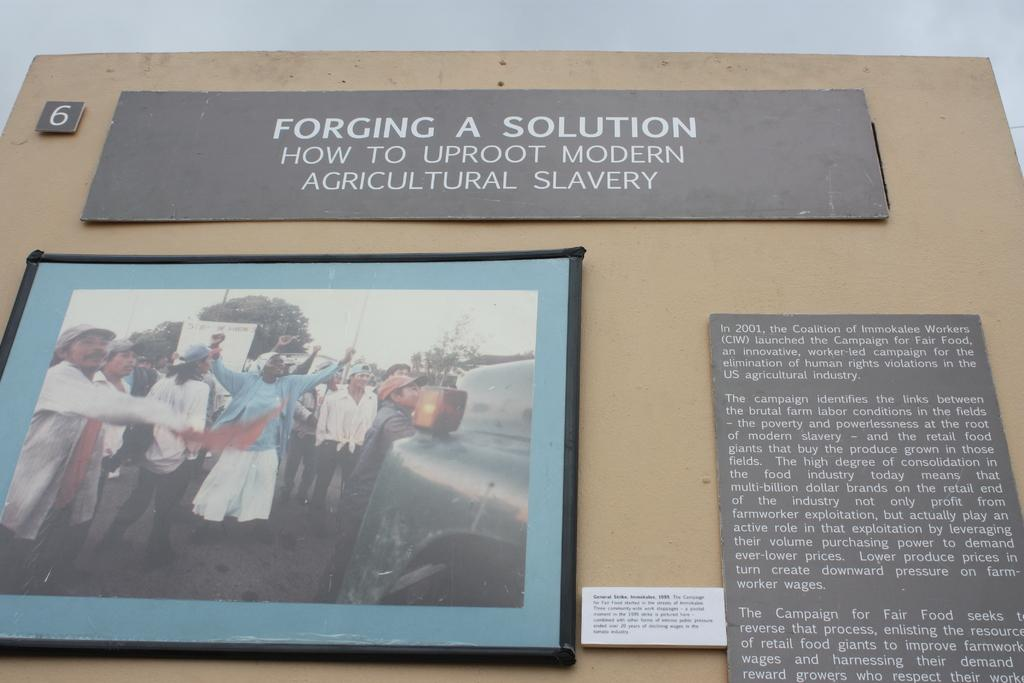<image>
Provide a brief description of the given image. a poster for Forging a Solution How to Uproot Modern Agricultural Slavery 